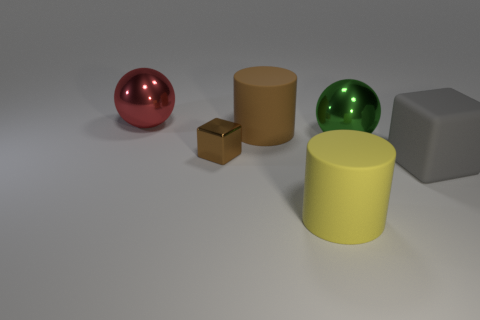Add 2 balls. How many objects exist? 8 Subtract all balls. How many objects are left? 4 Subtract all big green things. Subtract all big green metallic spheres. How many objects are left? 4 Add 2 small shiny objects. How many small shiny objects are left? 3 Add 6 tiny brown metallic objects. How many tiny brown metallic objects exist? 7 Subtract 0 yellow balls. How many objects are left? 6 